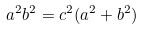<formula> <loc_0><loc_0><loc_500><loc_500>a ^ { 2 } b ^ { 2 } = c ^ { 2 } ( a ^ { 2 } + b ^ { 2 } )</formula> 